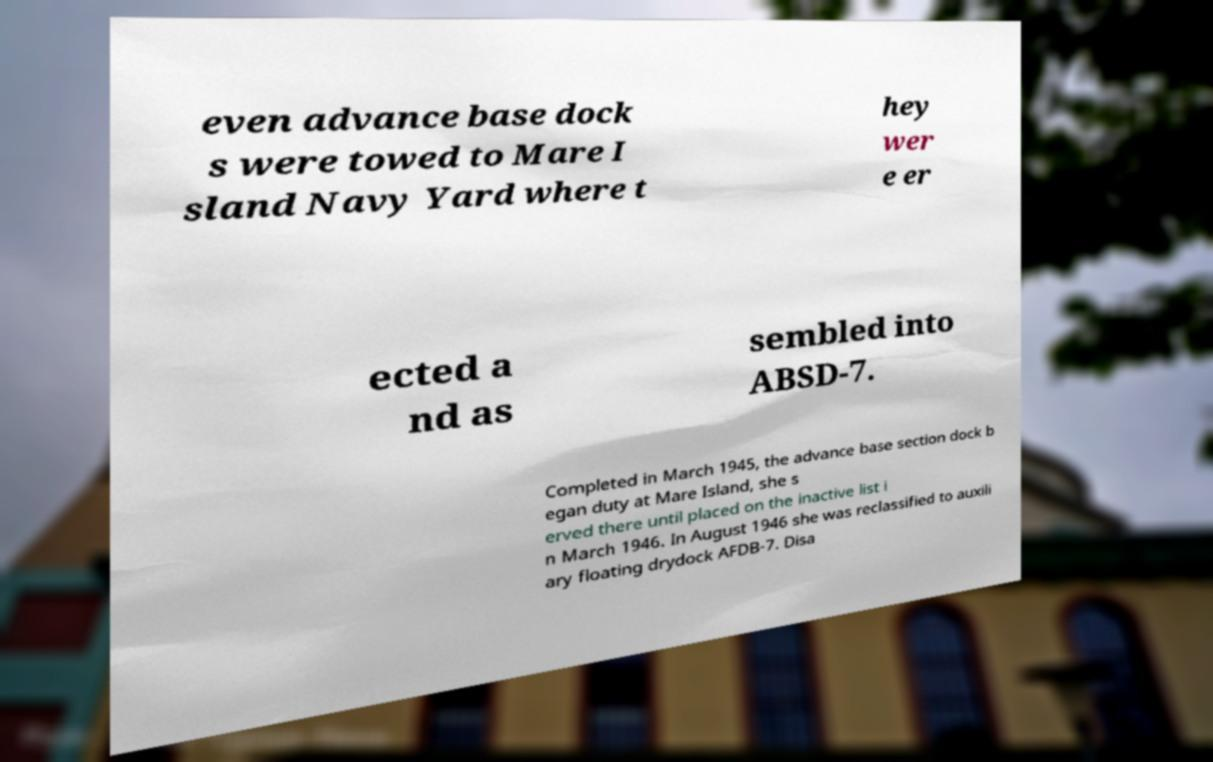For documentation purposes, I need the text within this image transcribed. Could you provide that? even advance base dock s were towed to Mare I sland Navy Yard where t hey wer e er ected a nd as sembled into ABSD-7. Completed in March 1945, the advance base section dock b egan duty at Mare Island, she s erved there until placed on the inactive list i n March 1946. In August 1946 she was reclassified to auxili ary floating drydock AFDB-7. Disa 